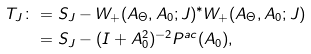Convert formula to latex. <formula><loc_0><loc_0><loc_500><loc_500>T _ { J } \colon & = S _ { J } - W _ { + } ( A _ { \Theta } , A _ { 0 } ; J ) ^ { * } W _ { + } ( A _ { \Theta } , A _ { 0 } ; J ) \\ & = S _ { J } - ( I + A _ { 0 } ^ { 2 } ) ^ { - 2 } P ^ { a c } ( A _ { 0 } ) ,</formula> 